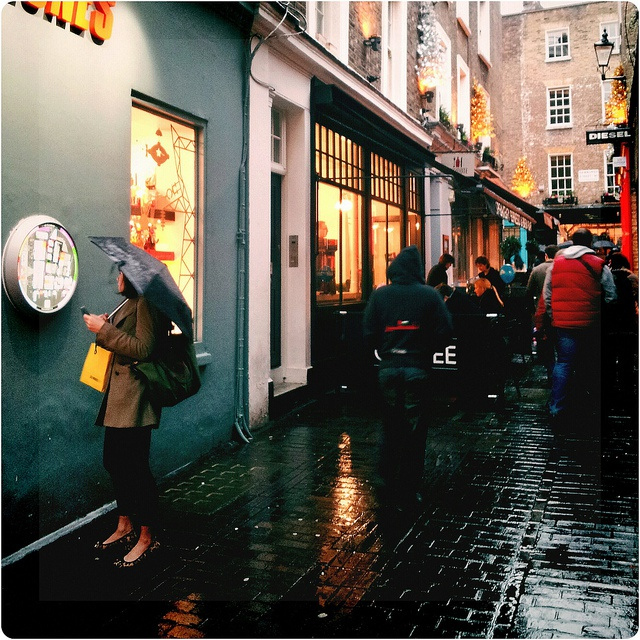Describe the objects in this image and their specific colors. I can see people in white, black, maroon, and gray tones, people in white, black, brown, maroon, and gray tones, people in white, black, brown, maroon, and navy tones, people in white, black, maroon, and brown tones, and umbrella in white, black, and gray tones in this image. 